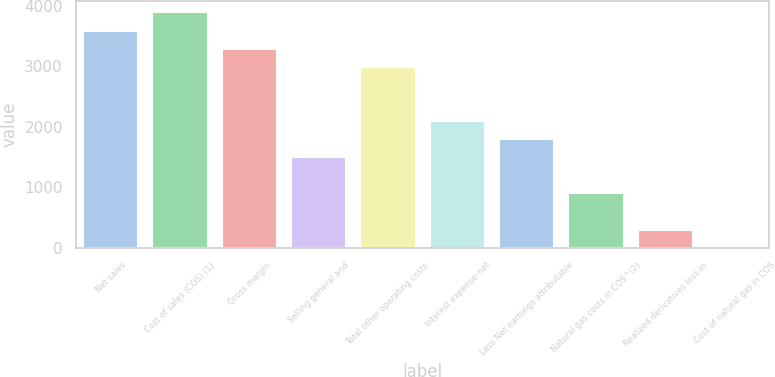<chart> <loc_0><loc_0><loc_500><loc_500><bar_chart><fcel>Net sales<fcel>Cost of sales (COS) (1)<fcel>Gross margin<fcel>Selling general and<fcel>Total other operating costs<fcel>Interest expense-net<fcel>Less Net earnings attributable<fcel>Natural gas costs in COS^(2)<fcel>Realized derivatives loss in<fcel>Cost of natural gas in COS<nl><fcel>3593.97<fcel>3893.44<fcel>3294.5<fcel>1497.68<fcel>2995.03<fcel>2096.62<fcel>1797.15<fcel>898.74<fcel>299.8<fcel>0.33<nl></chart> 